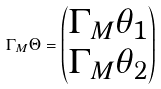Convert formula to latex. <formula><loc_0><loc_0><loc_500><loc_500>\Gamma _ { M } \Theta = \begin{pmatrix} \Gamma _ { M } \theta _ { 1 } \\ \Gamma _ { M } \theta _ { 2 } \end{pmatrix}</formula> 